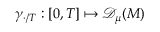<formula> <loc_0><loc_0><loc_500><loc_500>\gamma _ { \cdot / T } \colon [ 0 , T ] \mapsto { \ m a t h s c r { D } _ { \mu } ( M ) }</formula> 